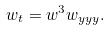<formula> <loc_0><loc_0><loc_500><loc_500>w _ { t } = w ^ { 3 } w _ { y y y } .</formula> 